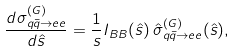Convert formula to latex. <formula><loc_0><loc_0><loc_500><loc_500>\frac { d \sigma ^ { ( G ) } _ { q \bar { q } \to e e } } { d \hat { s } } = \frac { 1 } { s } I _ { B B } ( \hat { s } ) \, \hat { \sigma } ^ { ( G ) } _ { q \bar { q } \to e e } ( \hat { s } ) ,</formula> 